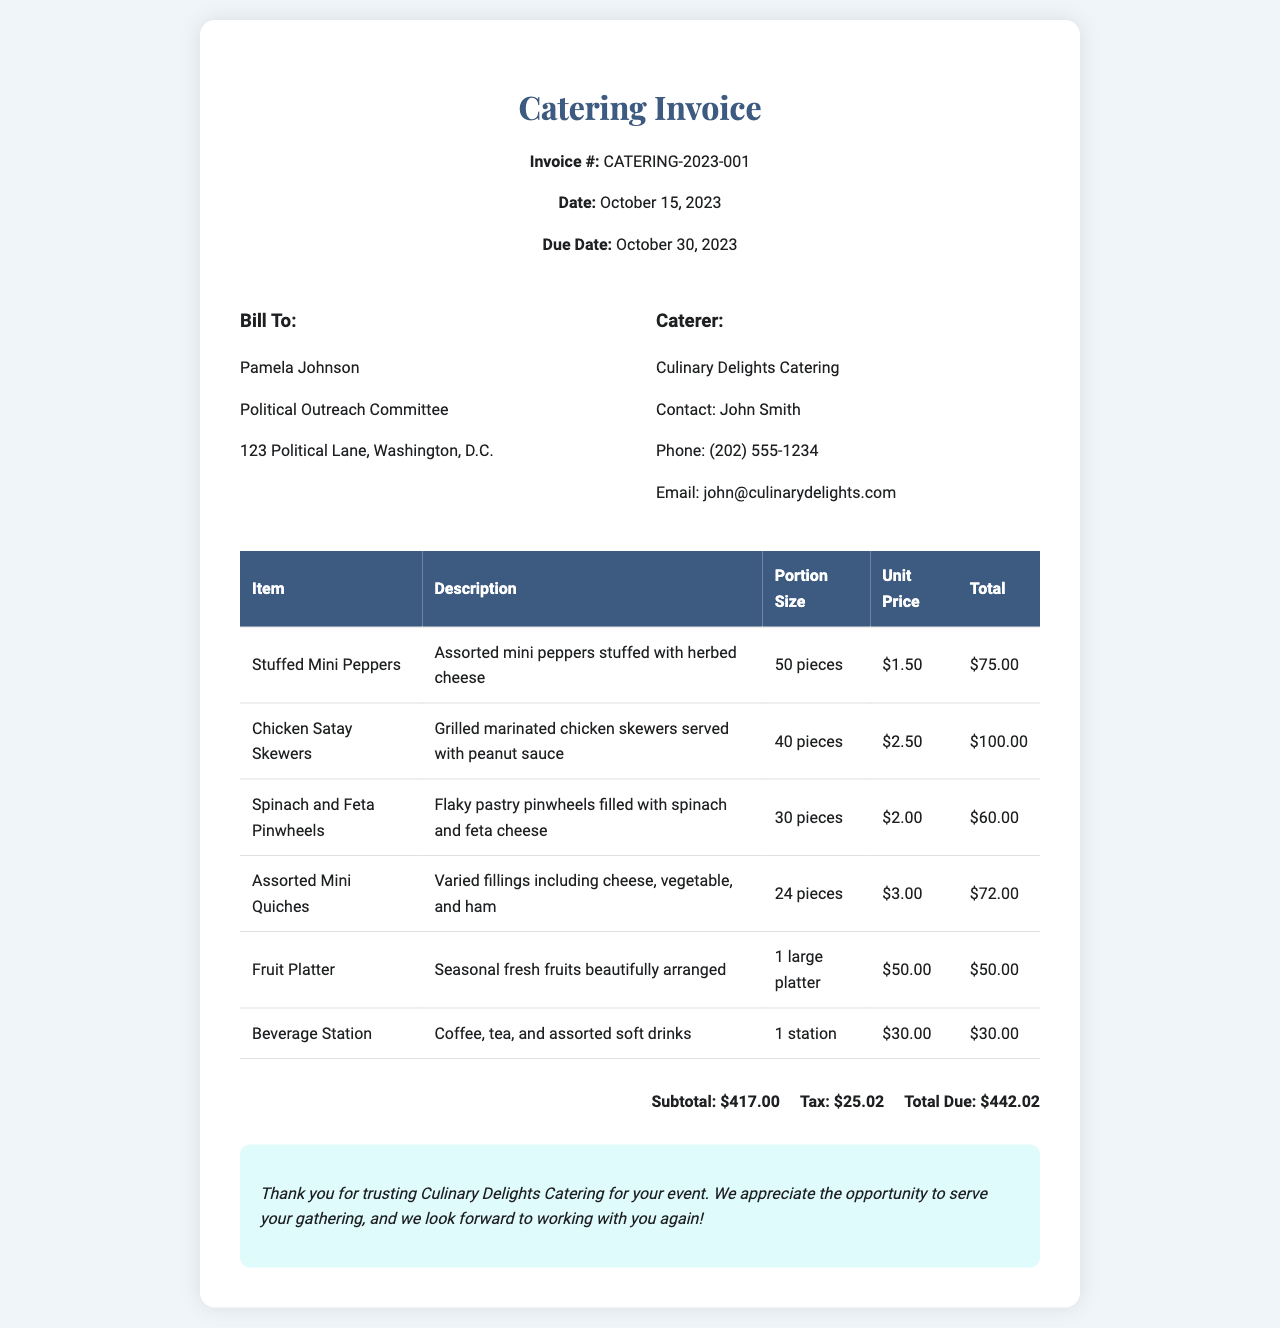What is the invoice number? The invoice number is listed at the top of the document.
Answer: CATERING-2023-001 What is the total due amount? The total due amount is calculated from the subtotal and tax in the summary section.
Answer: $442.02 Who is the contact person for the caterer? The contact information for the caterer includes a name, which is usually mentioned in the caterer details section.
Answer: John Smith How many stuffed mini peppers are included? The number of stuffed mini peppers can be found in the menu items table under portion size.
Answer: 50 pieces What is the subtotal before tax? The subtotal is found in the summary section, which lists amounts before any tax is added.
Answer: $417.00 What is the due date for the invoice? The due date is provided near the invoice details section at the top of the document.
Answer: October 30, 2023 How many varieties of mini quiches are available? The description of the assorted mini quiches in the menu indicates the variety present.
Answer: Three varieties What type of beverages are included in the catering? The beverage station description specifies the types of beverages offered during the catering service.
Answer: Coffee, tea, and assorted soft drinks What is the description for chicken satay skewers? The description is included in the menu items table for the specific item in question.
Answer: Grilled marinated chicken skewers served with peanut sauce 